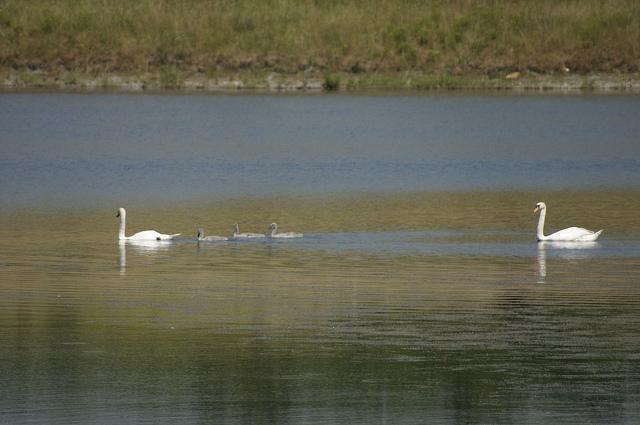How many ducklings are in the water?
Give a very brief answer. 3. How many birds can be spotted here?
Give a very brief answer. 5. How many birds are there?
Give a very brief answer. 5. How many blue train cars are there?
Give a very brief answer. 0. 